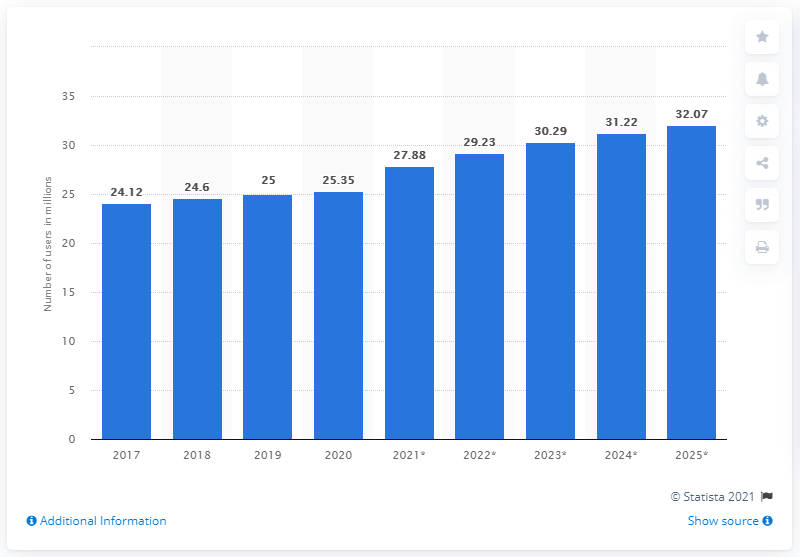Give some essential details in this illustration. According to projections, it is expected that there will be approximately 32.07 million social network users in Canada in 2023. In 2019, there were approximately 25.35 million social network users in Canada. 